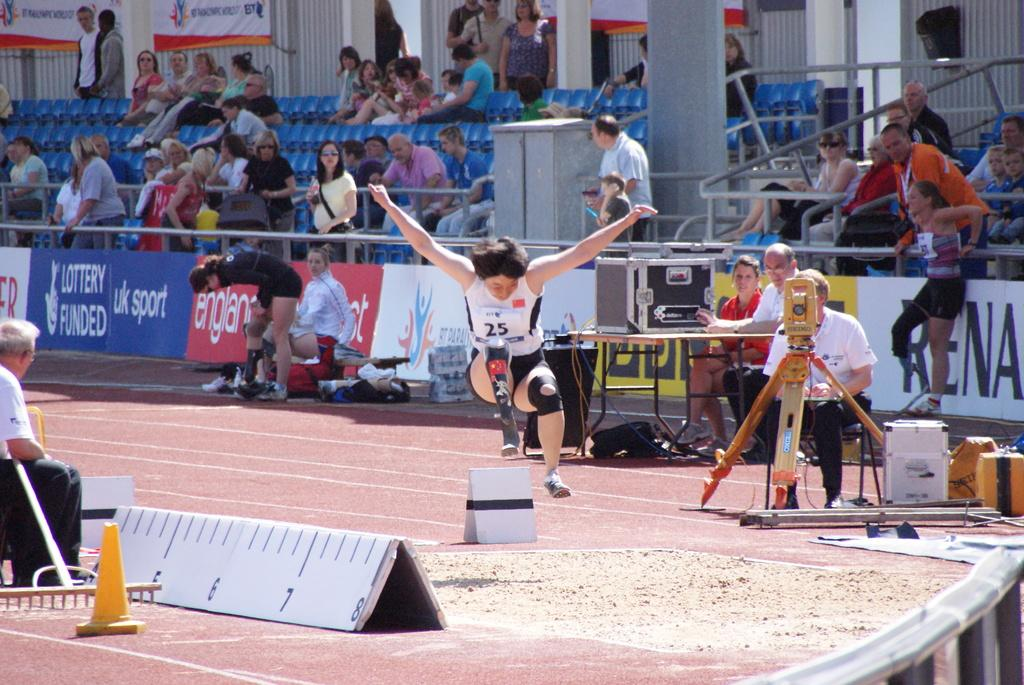<image>
Create a compact narrative representing the image presented. the number 25 is on the shirt of the person 